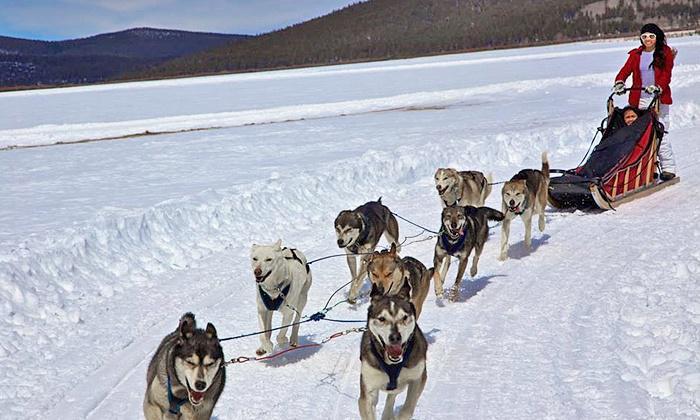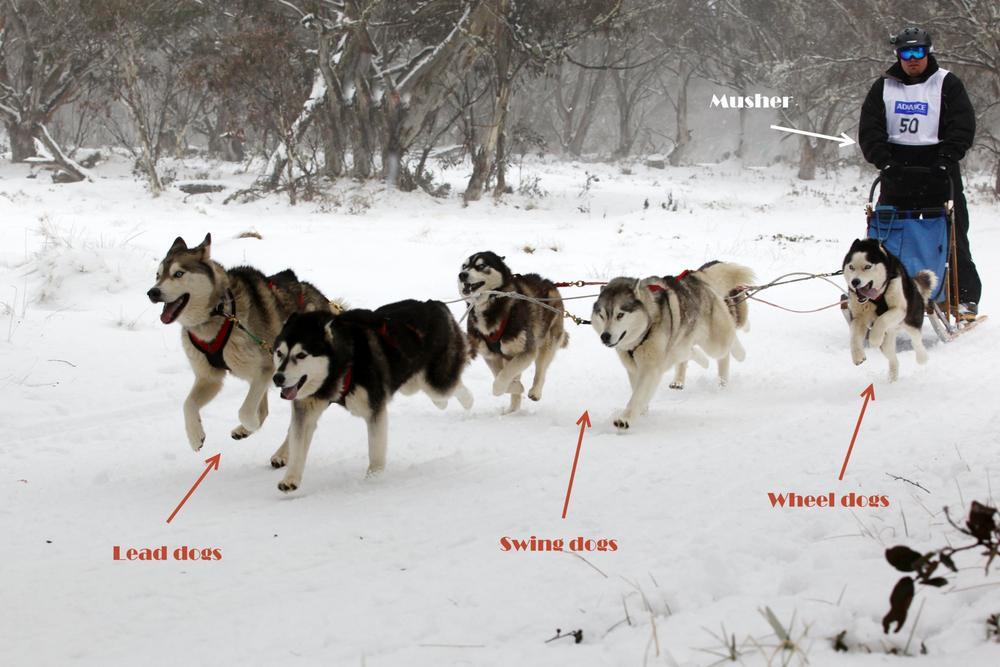The first image is the image on the left, the second image is the image on the right. Analyze the images presented: Is the assertion "The person in the image on the left is wearing a red jacket." valid? Answer yes or no. Yes. The first image is the image on the left, the second image is the image on the right. Assess this claim about the two images: "In one photo dogs are running, and in the other, they are still.". Correct or not? Answer yes or no. No. 